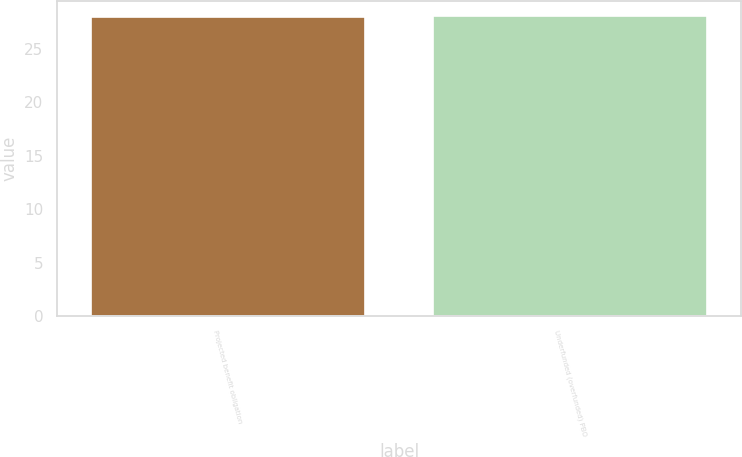Convert chart. <chart><loc_0><loc_0><loc_500><loc_500><bar_chart><fcel>Projected benefit obligation<fcel>Underfunded (overfunded) PBO<nl><fcel>28<fcel>28.1<nl></chart> 